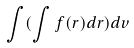<formula> <loc_0><loc_0><loc_500><loc_500>\int ( \int f ( r ) d r ) d v</formula> 